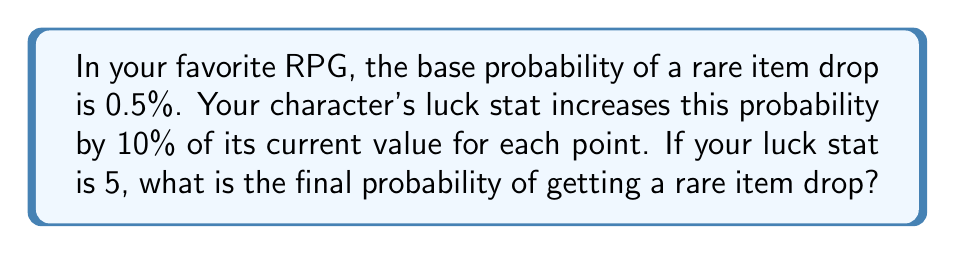Solve this math problem. Let's approach this step-by-step:

1) The base probability is 0.5% or 0.005 in decimal form.

2) Each luck point increases the probability by 10% of its current value.
   This can be represented as multiplying by 1.1 for each point.

3) With a luck stat of 5, we need to apply this increase 5 times.

4) Mathematically, this can be expressed as:

   $$P_{final} = 0.005 \times (1.1)^5$$

5) Let's calculate this:
   $$(1.1)^5 = 1.61051$$

6) Now, let's multiply by the base probability:

   $$P_{final} = 0.005 \times 1.61051 = 0.00805255$$

7) Convert to a percentage:

   $$0.00805255 \times 100\% = 0.805255\%$$
Answer: 0.805255% 